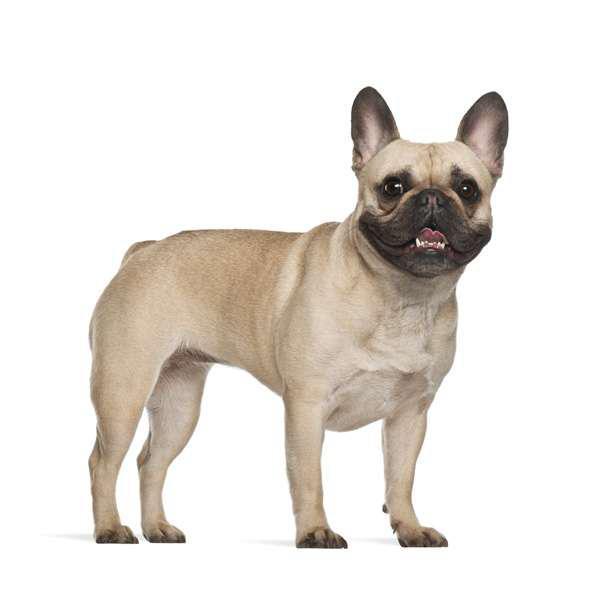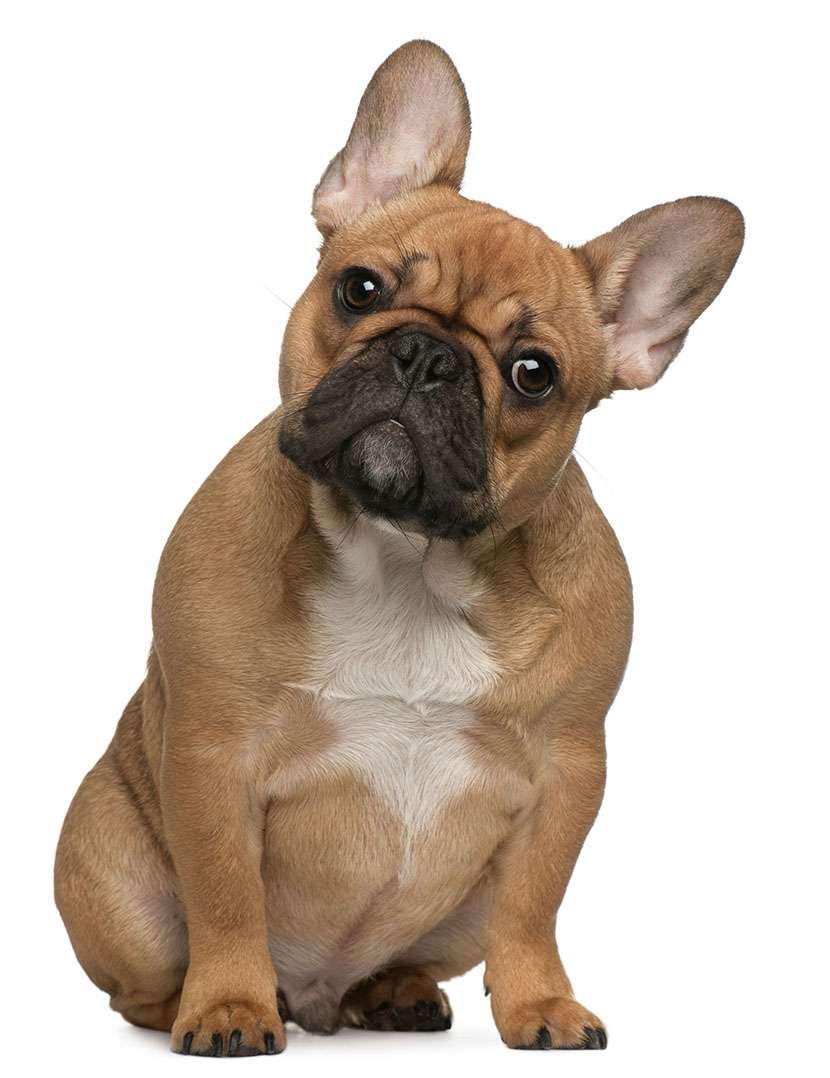The first image is the image on the left, the second image is the image on the right. Evaluate the accuracy of this statement regarding the images: "No less than one dog is outside.". Is it true? Answer yes or no. No. The first image is the image on the left, the second image is the image on the right. Examine the images to the left and right. Is the description "Each image contains one bulldog, and the dog on the left is standing while the dog on the right is sitting." accurate? Answer yes or no. Yes. 